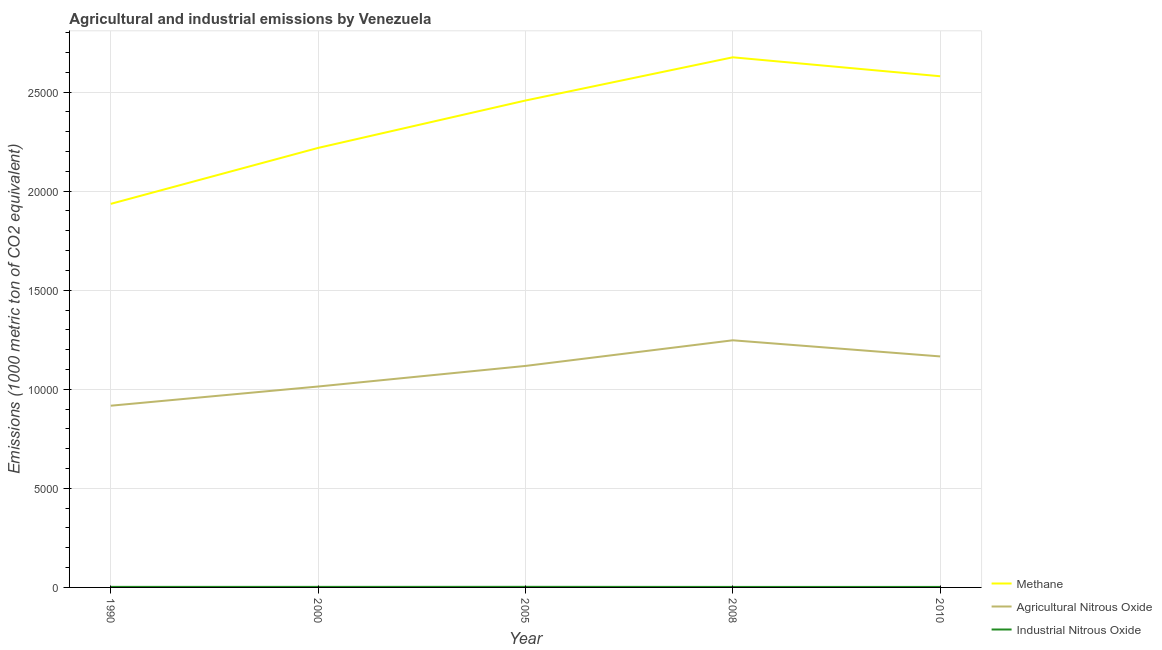How many different coloured lines are there?
Offer a terse response. 3. Is the number of lines equal to the number of legend labels?
Give a very brief answer. Yes. What is the amount of agricultural nitrous oxide emissions in 2010?
Offer a very short reply. 1.17e+04. Across all years, what is the maximum amount of methane emissions?
Provide a short and direct response. 2.68e+04. Across all years, what is the minimum amount of agricultural nitrous oxide emissions?
Give a very brief answer. 9170.6. In which year was the amount of agricultural nitrous oxide emissions minimum?
Make the answer very short. 1990. What is the total amount of methane emissions in the graph?
Keep it short and to the point. 1.19e+05. What is the difference between the amount of methane emissions in 2008 and that in 2010?
Your response must be concise. 955.7. What is the difference between the amount of methane emissions in 2008 and the amount of industrial nitrous oxide emissions in 2005?
Your answer should be compact. 2.67e+04. What is the average amount of industrial nitrous oxide emissions per year?
Offer a terse response. 27.4. In the year 2010, what is the difference between the amount of agricultural nitrous oxide emissions and amount of industrial nitrous oxide emissions?
Keep it short and to the point. 1.16e+04. In how many years, is the amount of methane emissions greater than 8000 metric ton?
Give a very brief answer. 5. What is the ratio of the amount of methane emissions in 1990 to that in 2005?
Make the answer very short. 0.79. What is the difference between the highest and the second highest amount of agricultural nitrous oxide emissions?
Offer a very short reply. 813.5. What is the difference between the highest and the lowest amount of methane emissions?
Make the answer very short. 7395.9. In how many years, is the amount of methane emissions greater than the average amount of methane emissions taken over all years?
Give a very brief answer. 3. Are the values on the major ticks of Y-axis written in scientific E-notation?
Ensure brevity in your answer.  No. Does the graph contain any zero values?
Your response must be concise. No. Does the graph contain grids?
Offer a terse response. Yes. Where does the legend appear in the graph?
Your response must be concise. Bottom right. How are the legend labels stacked?
Give a very brief answer. Vertical. What is the title of the graph?
Your answer should be very brief. Agricultural and industrial emissions by Venezuela. Does "Hydroelectric sources" appear as one of the legend labels in the graph?
Make the answer very short. No. What is the label or title of the Y-axis?
Offer a very short reply. Emissions (1000 metric ton of CO2 equivalent). What is the Emissions (1000 metric ton of CO2 equivalent) of Methane in 1990?
Offer a terse response. 1.94e+04. What is the Emissions (1000 metric ton of CO2 equivalent) in Agricultural Nitrous Oxide in 1990?
Your answer should be compact. 9170.6. What is the Emissions (1000 metric ton of CO2 equivalent) in Industrial Nitrous Oxide in 1990?
Your response must be concise. 27.9. What is the Emissions (1000 metric ton of CO2 equivalent) of Methane in 2000?
Your answer should be very brief. 2.22e+04. What is the Emissions (1000 metric ton of CO2 equivalent) in Agricultural Nitrous Oxide in 2000?
Give a very brief answer. 1.01e+04. What is the Emissions (1000 metric ton of CO2 equivalent) of Industrial Nitrous Oxide in 2000?
Provide a succinct answer. 27.9. What is the Emissions (1000 metric ton of CO2 equivalent) in Methane in 2005?
Give a very brief answer. 2.46e+04. What is the Emissions (1000 metric ton of CO2 equivalent) in Agricultural Nitrous Oxide in 2005?
Provide a succinct answer. 1.12e+04. What is the Emissions (1000 metric ton of CO2 equivalent) in Industrial Nitrous Oxide in 2005?
Your response must be concise. 30.1. What is the Emissions (1000 metric ton of CO2 equivalent) of Methane in 2008?
Make the answer very short. 2.68e+04. What is the Emissions (1000 metric ton of CO2 equivalent) in Agricultural Nitrous Oxide in 2008?
Offer a terse response. 1.25e+04. What is the Emissions (1000 metric ton of CO2 equivalent) in Industrial Nitrous Oxide in 2008?
Keep it short and to the point. 25.4. What is the Emissions (1000 metric ton of CO2 equivalent) of Methane in 2010?
Keep it short and to the point. 2.58e+04. What is the Emissions (1000 metric ton of CO2 equivalent) of Agricultural Nitrous Oxide in 2010?
Your response must be concise. 1.17e+04. What is the Emissions (1000 metric ton of CO2 equivalent) in Industrial Nitrous Oxide in 2010?
Ensure brevity in your answer.  25.7. Across all years, what is the maximum Emissions (1000 metric ton of CO2 equivalent) in Methane?
Keep it short and to the point. 2.68e+04. Across all years, what is the maximum Emissions (1000 metric ton of CO2 equivalent) of Agricultural Nitrous Oxide?
Provide a succinct answer. 1.25e+04. Across all years, what is the maximum Emissions (1000 metric ton of CO2 equivalent) in Industrial Nitrous Oxide?
Keep it short and to the point. 30.1. Across all years, what is the minimum Emissions (1000 metric ton of CO2 equivalent) in Methane?
Provide a succinct answer. 1.94e+04. Across all years, what is the minimum Emissions (1000 metric ton of CO2 equivalent) in Agricultural Nitrous Oxide?
Provide a short and direct response. 9170.6. Across all years, what is the minimum Emissions (1000 metric ton of CO2 equivalent) of Industrial Nitrous Oxide?
Offer a terse response. 25.4. What is the total Emissions (1000 metric ton of CO2 equivalent) in Methane in the graph?
Your answer should be compact. 1.19e+05. What is the total Emissions (1000 metric ton of CO2 equivalent) in Agricultural Nitrous Oxide in the graph?
Offer a terse response. 5.46e+04. What is the total Emissions (1000 metric ton of CO2 equivalent) in Industrial Nitrous Oxide in the graph?
Your answer should be compact. 137. What is the difference between the Emissions (1000 metric ton of CO2 equivalent) in Methane in 1990 and that in 2000?
Provide a short and direct response. -2823.3. What is the difference between the Emissions (1000 metric ton of CO2 equivalent) in Agricultural Nitrous Oxide in 1990 and that in 2000?
Make the answer very short. -969. What is the difference between the Emissions (1000 metric ton of CO2 equivalent) of Industrial Nitrous Oxide in 1990 and that in 2000?
Offer a terse response. 0. What is the difference between the Emissions (1000 metric ton of CO2 equivalent) in Methane in 1990 and that in 2005?
Provide a succinct answer. -5215.1. What is the difference between the Emissions (1000 metric ton of CO2 equivalent) of Agricultural Nitrous Oxide in 1990 and that in 2005?
Your answer should be very brief. -2007.4. What is the difference between the Emissions (1000 metric ton of CO2 equivalent) in Methane in 1990 and that in 2008?
Offer a very short reply. -7395.9. What is the difference between the Emissions (1000 metric ton of CO2 equivalent) in Agricultural Nitrous Oxide in 1990 and that in 2008?
Your answer should be very brief. -3301.1. What is the difference between the Emissions (1000 metric ton of CO2 equivalent) of Methane in 1990 and that in 2010?
Offer a terse response. -6440.2. What is the difference between the Emissions (1000 metric ton of CO2 equivalent) in Agricultural Nitrous Oxide in 1990 and that in 2010?
Keep it short and to the point. -2487.6. What is the difference between the Emissions (1000 metric ton of CO2 equivalent) of Industrial Nitrous Oxide in 1990 and that in 2010?
Offer a very short reply. 2.2. What is the difference between the Emissions (1000 metric ton of CO2 equivalent) of Methane in 2000 and that in 2005?
Make the answer very short. -2391.8. What is the difference between the Emissions (1000 metric ton of CO2 equivalent) in Agricultural Nitrous Oxide in 2000 and that in 2005?
Provide a succinct answer. -1038.4. What is the difference between the Emissions (1000 metric ton of CO2 equivalent) in Industrial Nitrous Oxide in 2000 and that in 2005?
Provide a short and direct response. -2.2. What is the difference between the Emissions (1000 metric ton of CO2 equivalent) of Methane in 2000 and that in 2008?
Offer a very short reply. -4572.6. What is the difference between the Emissions (1000 metric ton of CO2 equivalent) of Agricultural Nitrous Oxide in 2000 and that in 2008?
Your answer should be very brief. -2332.1. What is the difference between the Emissions (1000 metric ton of CO2 equivalent) of Industrial Nitrous Oxide in 2000 and that in 2008?
Your response must be concise. 2.5. What is the difference between the Emissions (1000 metric ton of CO2 equivalent) in Methane in 2000 and that in 2010?
Your answer should be compact. -3616.9. What is the difference between the Emissions (1000 metric ton of CO2 equivalent) in Agricultural Nitrous Oxide in 2000 and that in 2010?
Make the answer very short. -1518.6. What is the difference between the Emissions (1000 metric ton of CO2 equivalent) of Industrial Nitrous Oxide in 2000 and that in 2010?
Offer a very short reply. 2.2. What is the difference between the Emissions (1000 metric ton of CO2 equivalent) of Methane in 2005 and that in 2008?
Offer a very short reply. -2180.8. What is the difference between the Emissions (1000 metric ton of CO2 equivalent) in Agricultural Nitrous Oxide in 2005 and that in 2008?
Offer a terse response. -1293.7. What is the difference between the Emissions (1000 metric ton of CO2 equivalent) of Methane in 2005 and that in 2010?
Your answer should be very brief. -1225.1. What is the difference between the Emissions (1000 metric ton of CO2 equivalent) in Agricultural Nitrous Oxide in 2005 and that in 2010?
Offer a very short reply. -480.2. What is the difference between the Emissions (1000 metric ton of CO2 equivalent) of Industrial Nitrous Oxide in 2005 and that in 2010?
Ensure brevity in your answer.  4.4. What is the difference between the Emissions (1000 metric ton of CO2 equivalent) in Methane in 2008 and that in 2010?
Ensure brevity in your answer.  955.7. What is the difference between the Emissions (1000 metric ton of CO2 equivalent) of Agricultural Nitrous Oxide in 2008 and that in 2010?
Provide a short and direct response. 813.5. What is the difference between the Emissions (1000 metric ton of CO2 equivalent) of Industrial Nitrous Oxide in 2008 and that in 2010?
Keep it short and to the point. -0.3. What is the difference between the Emissions (1000 metric ton of CO2 equivalent) in Methane in 1990 and the Emissions (1000 metric ton of CO2 equivalent) in Agricultural Nitrous Oxide in 2000?
Give a very brief answer. 9217.6. What is the difference between the Emissions (1000 metric ton of CO2 equivalent) of Methane in 1990 and the Emissions (1000 metric ton of CO2 equivalent) of Industrial Nitrous Oxide in 2000?
Your response must be concise. 1.93e+04. What is the difference between the Emissions (1000 metric ton of CO2 equivalent) in Agricultural Nitrous Oxide in 1990 and the Emissions (1000 metric ton of CO2 equivalent) in Industrial Nitrous Oxide in 2000?
Your answer should be very brief. 9142.7. What is the difference between the Emissions (1000 metric ton of CO2 equivalent) in Methane in 1990 and the Emissions (1000 metric ton of CO2 equivalent) in Agricultural Nitrous Oxide in 2005?
Offer a terse response. 8179.2. What is the difference between the Emissions (1000 metric ton of CO2 equivalent) in Methane in 1990 and the Emissions (1000 metric ton of CO2 equivalent) in Industrial Nitrous Oxide in 2005?
Your answer should be very brief. 1.93e+04. What is the difference between the Emissions (1000 metric ton of CO2 equivalent) of Agricultural Nitrous Oxide in 1990 and the Emissions (1000 metric ton of CO2 equivalent) of Industrial Nitrous Oxide in 2005?
Your answer should be very brief. 9140.5. What is the difference between the Emissions (1000 metric ton of CO2 equivalent) in Methane in 1990 and the Emissions (1000 metric ton of CO2 equivalent) in Agricultural Nitrous Oxide in 2008?
Offer a terse response. 6885.5. What is the difference between the Emissions (1000 metric ton of CO2 equivalent) of Methane in 1990 and the Emissions (1000 metric ton of CO2 equivalent) of Industrial Nitrous Oxide in 2008?
Offer a terse response. 1.93e+04. What is the difference between the Emissions (1000 metric ton of CO2 equivalent) in Agricultural Nitrous Oxide in 1990 and the Emissions (1000 metric ton of CO2 equivalent) in Industrial Nitrous Oxide in 2008?
Offer a terse response. 9145.2. What is the difference between the Emissions (1000 metric ton of CO2 equivalent) in Methane in 1990 and the Emissions (1000 metric ton of CO2 equivalent) in Agricultural Nitrous Oxide in 2010?
Offer a very short reply. 7699. What is the difference between the Emissions (1000 metric ton of CO2 equivalent) of Methane in 1990 and the Emissions (1000 metric ton of CO2 equivalent) of Industrial Nitrous Oxide in 2010?
Provide a short and direct response. 1.93e+04. What is the difference between the Emissions (1000 metric ton of CO2 equivalent) in Agricultural Nitrous Oxide in 1990 and the Emissions (1000 metric ton of CO2 equivalent) in Industrial Nitrous Oxide in 2010?
Give a very brief answer. 9144.9. What is the difference between the Emissions (1000 metric ton of CO2 equivalent) of Methane in 2000 and the Emissions (1000 metric ton of CO2 equivalent) of Agricultural Nitrous Oxide in 2005?
Offer a terse response. 1.10e+04. What is the difference between the Emissions (1000 metric ton of CO2 equivalent) of Methane in 2000 and the Emissions (1000 metric ton of CO2 equivalent) of Industrial Nitrous Oxide in 2005?
Provide a succinct answer. 2.22e+04. What is the difference between the Emissions (1000 metric ton of CO2 equivalent) in Agricultural Nitrous Oxide in 2000 and the Emissions (1000 metric ton of CO2 equivalent) in Industrial Nitrous Oxide in 2005?
Keep it short and to the point. 1.01e+04. What is the difference between the Emissions (1000 metric ton of CO2 equivalent) of Methane in 2000 and the Emissions (1000 metric ton of CO2 equivalent) of Agricultural Nitrous Oxide in 2008?
Provide a short and direct response. 9708.8. What is the difference between the Emissions (1000 metric ton of CO2 equivalent) of Methane in 2000 and the Emissions (1000 metric ton of CO2 equivalent) of Industrial Nitrous Oxide in 2008?
Your response must be concise. 2.22e+04. What is the difference between the Emissions (1000 metric ton of CO2 equivalent) in Agricultural Nitrous Oxide in 2000 and the Emissions (1000 metric ton of CO2 equivalent) in Industrial Nitrous Oxide in 2008?
Keep it short and to the point. 1.01e+04. What is the difference between the Emissions (1000 metric ton of CO2 equivalent) in Methane in 2000 and the Emissions (1000 metric ton of CO2 equivalent) in Agricultural Nitrous Oxide in 2010?
Provide a short and direct response. 1.05e+04. What is the difference between the Emissions (1000 metric ton of CO2 equivalent) in Methane in 2000 and the Emissions (1000 metric ton of CO2 equivalent) in Industrial Nitrous Oxide in 2010?
Your answer should be very brief. 2.22e+04. What is the difference between the Emissions (1000 metric ton of CO2 equivalent) in Agricultural Nitrous Oxide in 2000 and the Emissions (1000 metric ton of CO2 equivalent) in Industrial Nitrous Oxide in 2010?
Provide a succinct answer. 1.01e+04. What is the difference between the Emissions (1000 metric ton of CO2 equivalent) in Methane in 2005 and the Emissions (1000 metric ton of CO2 equivalent) in Agricultural Nitrous Oxide in 2008?
Your answer should be compact. 1.21e+04. What is the difference between the Emissions (1000 metric ton of CO2 equivalent) in Methane in 2005 and the Emissions (1000 metric ton of CO2 equivalent) in Industrial Nitrous Oxide in 2008?
Your answer should be very brief. 2.45e+04. What is the difference between the Emissions (1000 metric ton of CO2 equivalent) of Agricultural Nitrous Oxide in 2005 and the Emissions (1000 metric ton of CO2 equivalent) of Industrial Nitrous Oxide in 2008?
Provide a succinct answer. 1.12e+04. What is the difference between the Emissions (1000 metric ton of CO2 equivalent) of Methane in 2005 and the Emissions (1000 metric ton of CO2 equivalent) of Agricultural Nitrous Oxide in 2010?
Offer a terse response. 1.29e+04. What is the difference between the Emissions (1000 metric ton of CO2 equivalent) in Methane in 2005 and the Emissions (1000 metric ton of CO2 equivalent) in Industrial Nitrous Oxide in 2010?
Provide a short and direct response. 2.45e+04. What is the difference between the Emissions (1000 metric ton of CO2 equivalent) in Agricultural Nitrous Oxide in 2005 and the Emissions (1000 metric ton of CO2 equivalent) in Industrial Nitrous Oxide in 2010?
Ensure brevity in your answer.  1.12e+04. What is the difference between the Emissions (1000 metric ton of CO2 equivalent) of Methane in 2008 and the Emissions (1000 metric ton of CO2 equivalent) of Agricultural Nitrous Oxide in 2010?
Offer a terse response. 1.51e+04. What is the difference between the Emissions (1000 metric ton of CO2 equivalent) of Methane in 2008 and the Emissions (1000 metric ton of CO2 equivalent) of Industrial Nitrous Oxide in 2010?
Give a very brief answer. 2.67e+04. What is the difference between the Emissions (1000 metric ton of CO2 equivalent) in Agricultural Nitrous Oxide in 2008 and the Emissions (1000 metric ton of CO2 equivalent) in Industrial Nitrous Oxide in 2010?
Offer a terse response. 1.24e+04. What is the average Emissions (1000 metric ton of CO2 equivalent) of Methane per year?
Offer a terse response. 2.37e+04. What is the average Emissions (1000 metric ton of CO2 equivalent) in Agricultural Nitrous Oxide per year?
Your response must be concise. 1.09e+04. What is the average Emissions (1000 metric ton of CO2 equivalent) in Industrial Nitrous Oxide per year?
Provide a short and direct response. 27.4. In the year 1990, what is the difference between the Emissions (1000 metric ton of CO2 equivalent) in Methane and Emissions (1000 metric ton of CO2 equivalent) in Agricultural Nitrous Oxide?
Provide a short and direct response. 1.02e+04. In the year 1990, what is the difference between the Emissions (1000 metric ton of CO2 equivalent) of Methane and Emissions (1000 metric ton of CO2 equivalent) of Industrial Nitrous Oxide?
Your answer should be compact. 1.93e+04. In the year 1990, what is the difference between the Emissions (1000 metric ton of CO2 equivalent) of Agricultural Nitrous Oxide and Emissions (1000 metric ton of CO2 equivalent) of Industrial Nitrous Oxide?
Provide a succinct answer. 9142.7. In the year 2000, what is the difference between the Emissions (1000 metric ton of CO2 equivalent) of Methane and Emissions (1000 metric ton of CO2 equivalent) of Agricultural Nitrous Oxide?
Your answer should be compact. 1.20e+04. In the year 2000, what is the difference between the Emissions (1000 metric ton of CO2 equivalent) of Methane and Emissions (1000 metric ton of CO2 equivalent) of Industrial Nitrous Oxide?
Your answer should be very brief. 2.22e+04. In the year 2000, what is the difference between the Emissions (1000 metric ton of CO2 equivalent) in Agricultural Nitrous Oxide and Emissions (1000 metric ton of CO2 equivalent) in Industrial Nitrous Oxide?
Make the answer very short. 1.01e+04. In the year 2005, what is the difference between the Emissions (1000 metric ton of CO2 equivalent) of Methane and Emissions (1000 metric ton of CO2 equivalent) of Agricultural Nitrous Oxide?
Offer a very short reply. 1.34e+04. In the year 2005, what is the difference between the Emissions (1000 metric ton of CO2 equivalent) in Methane and Emissions (1000 metric ton of CO2 equivalent) in Industrial Nitrous Oxide?
Make the answer very short. 2.45e+04. In the year 2005, what is the difference between the Emissions (1000 metric ton of CO2 equivalent) of Agricultural Nitrous Oxide and Emissions (1000 metric ton of CO2 equivalent) of Industrial Nitrous Oxide?
Your response must be concise. 1.11e+04. In the year 2008, what is the difference between the Emissions (1000 metric ton of CO2 equivalent) in Methane and Emissions (1000 metric ton of CO2 equivalent) in Agricultural Nitrous Oxide?
Your answer should be very brief. 1.43e+04. In the year 2008, what is the difference between the Emissions (1000 metric ton of CO2 equivalent) in Methane and Emissions (1000 metric ton of CO2 equivalent) in Industrial Nitrous Oxide?
Make the answer very short. 2.67e+04. In the year 2008, what is the difference between the Emissions (1000 metric ton of CO2 equivalent) in Agricultural Nitrous Oxide and Emissions (1000 metric ton of CO2 equivalent) in Industrial Nitrous Oxide?
Provide a short and direct response. 1.24e+04. In the year 2010, what is the difference between the Emissions (1000 metric ton of CO2 equivalent) in Methane and Emissions (1000 metric ton of CO2 equivalent) in Agricultural Nitrous Oxide?
Provide a short and direct response. 1.41e+04. In the year 2010, what is the difference between the Emissions (1000 metric ton of CO2 equivalent) in Methane and Emissions (1000 metric ton of CO2 equivalent) in Industrial Nitrous Oxide?
Provide a short and direct response. 2.58e+04. In the year 2010, what is the difference between the Emissions (1000 metric ton of CO2 equivalent) in Agricultural Nitrous Oxide and Emissions (1000 metric ton of CO2 equivalent) in Industrial Nitrous Oxide?
Your answer should be very brief. 1.16e+04. What is the ratio of the Emissions (1000 metric ton of CO2 equivalent) in Methane in 1990 to that in 2000?
Give a very brief answer. 0.87. What is the ratio of the Emissions (1000 metric ton of CO2 equivalent) of Agricultural Nitrous Oxide in 1990 to that in 2000?
Make the answer very short. 0.9. What is the ratio of the Emissions (1000 metric ton of CO2 equivalent) of Methane in 1990 to that in 2005?
Offer a very short reply. 0.79. What is the ratio of the Emissions (1000 metric ton of CO2 equivalent) of Agricultural Nitrous Oxide in 1990 to that in 2005?
Keep it short and to the point. 0.82. What is the ratio of the Emissions (1000 metric ton of CO2 equivalent) of Industrial Nitrous Oxide in 1990 to that in 2005?
Give a very brief answer. 0.93. What is the ratio of the Emissions (1000 metric ton of CO2 equivalent) of Methane in 1990 to that in 2008?
Ensure brevity in your answer.  0.72. What is the ratio of the Emissions (1000 metric ton of CO2 equivalent) in Agricultural Nitrous Oxide in 1990 to that in 2008?
Offer a terse response. 0.74. What is the ratio of the Emissions (1000 metric ton of CO2 equivalent) in Industrial Nitrous Oxide in 1990 to that in 2008?
Your response must be concise. 1.1. What is the ratio of the Emissions (1000 metric ton of CO2 equivalent) of Methane in 1990 to that in 2010?
Your response must be concise. 0.75. What is the ratio of the Emissions (1000 metric ton of CO2 equivalent) of Agricultural Nitrous Oxide in 1990 to that in 2010?
Your response must be concise. 0.79. What is the ratio of the Emissions (1000 metric ton of CO2 equivalent) of Industrial Nitrous Oxide in 1990 to that in 2010?
Your answer should be very brief. 1.09. What is the ratio of the Emissions (1000 metric ton of CO2 equivalent) in Methane in 2000 to that in 2005?
Make the answer very short. 0.9. What is the ratio of the Emissions (1000 metric ton of CO2 equivalent) in Agricultural Nitrous Oxide in 2000 to that in 2005?
Give a very brief answer. 0.91. What is the ratio of the Emissions (1000 metric ton of CO2 equivalent) of Industrial Nitrous Oxide in 2000 to that in 2005?
Your answer should be compact. 0.93. What is the ratio of the Emissions (1000 metric ton of CO2 equivalent) of Methane in 2000 to that in 2008?
Give a very brief answer. 0.83. What is the ratio of the Emissions (1000 metric ton of CO2 equivalent) in Agricultural Nitrous Oxide in 2000 to that in 2008?
Ensure brevity in your answer.  0.81. What is the ratio of the Emissions (1000 metric ton of CO2 equivalent) in Industrial Nitrous Oxide in 2000 to that in 2008?
Give a very brief answer. 1.1. What is the ratio of the Emissions (1000 metric ton of CO2 equivalent) of Methane in 2000 to that in 2010?
Your response must be concise. 0.86. What is the ratio of the Emissions (1000 metric ton of CO2 equivalent) in Agricultural Nitrous Oxide in 2000 to that in 2010?
Make the answer very short. 0.87. What is the ratio of the Emissions (1000 metric ton of CO2 equivalent) in Industrial Nitrous Oxide in 2000 to that in 2010?
Ensure brevity in your answer.  1.09. What is the ratio of the Emissions (1000 metric ton of CO2 equivalent) of Methane in 2005 to that in 2008?
Give a very brief answer. 0.92. What is the ratio of the Emissions (1000 metric ton of CO2 equivalent) of Agricultural Nitrous Oxide in 2005 to that in 2008?
Offer a very short reply. 0.9. What is the ratio of the Emissions (1000 metric ton of CO2 equivalent) of Industrial Nitrous Oxide in 2005 to that in 2008?
Ensure brevity in your answer.  1.19. What is the ratio of the Emissions (1000 metric ton of CO2 equivalent) of Methane in 2005 to that in 2010?
Your answer should be very brief. 0.95. What is the ratio of the Emissions (1000 metric ton of CO2 equivalent) of Agricultural Nitrous Oxide in 2005 to that in 2010?
Offer a very short reply. 0.96. What is the ratio of the Emissions (1000 metric ton of CO2 equivalent) of Industrial Nitrous Oxide in 2005 to that in 2010?
Offer a very short reply. 1.17. What is the ratio of the Emissions (1000 metric ton of CO2 equivalent) in Methane in 2008 to that in 2010?
Your response must be concise. 1.04. What is the ratio of the Emissions (1000 metric ton of CO2 equivalent) of Agricultural Nitrous Oxide in 2008 to that in 2010?
Offer a terse response. 1.07. What is the ratio of the Emissions (1000 metric ton of CO2 equivalent) in Industrial Nitrous Oxide in 2008 to that in 2010?
Your response must be concise. 0.99. What is the difference between the highest and the second highest Emissions (1000 metric ton of CO2 equivalent) of Methane?
Keep it short and to the point. 955.7. What is the difference between the highest and the second highest Emissions (1000 metric ton of CO2 equivalent) of Agricultural Nitrous Oxide?
Offer a terse response. 813.5. What is the difference between the highest and the second highest Emissions (1000 metric ton of CO2 equivalent) in Industrial Nitrous Oxide?
Ensure brevity in your answer.  2.2. What is the difference between the highest and the lowest Emissions (1000 metric ton of CO2 equivalent) in Methane?
Ensure brevity in your answer.  7395.9. What is the difference between the highest and the lowest Emissions (1000 metric ton of CO2 equivalent) of Agricultural Nitrous Oxide?
Provide a succinct answer. 3301.1. 